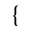Convert formula to latex. <formula><loc_0><loc_0><loc_500><loc_500>\{</formula> 